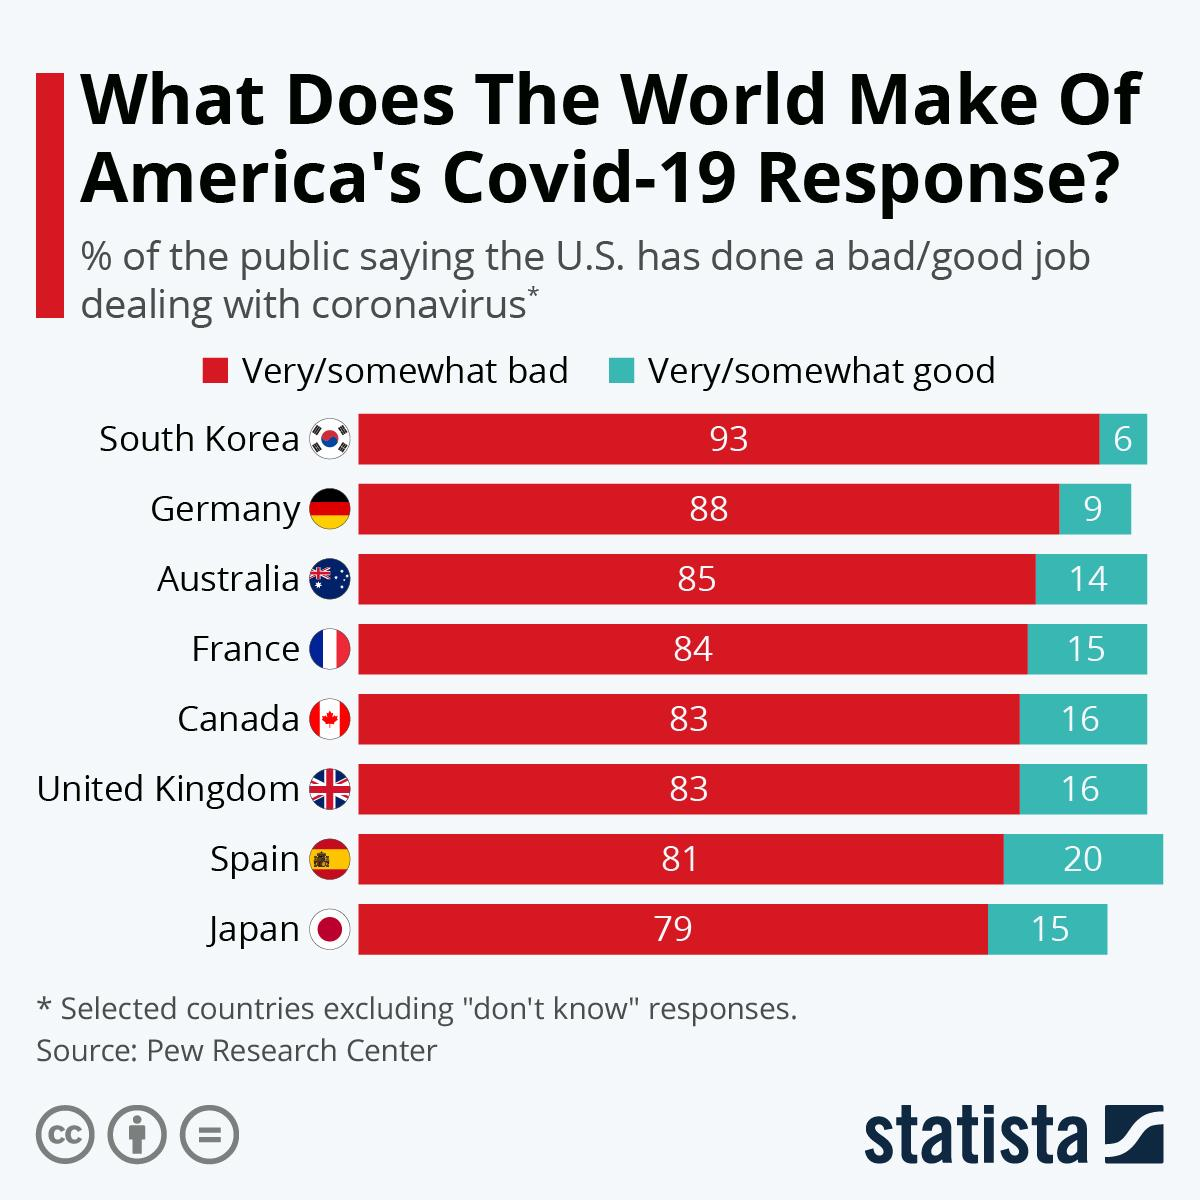Draw attention to some important aspects in this diagram. According to a recent survey, a majority of the public believe that the United States has done a good job in dealing with the COVID-19 pandemic in Canada. Specifically, 16% of the respondents stated that the U.S. has done an excellent job, while another 48% believed that the U.S. has done a good job. According to a recent survey, a significant percentage of the public believe that the United States has handled the coronavirus outbreak in Australia effectively. According to recent public opinion in France, 84% of the population believe that the United States has performed poorly in addressing the COVID-19 pandemic. A large majority of the public believe that the United States has performed poorly in dealing with the COVID-19 pandemic in Japan, with 79% of the public expressing this sentiment. According to recent polls, a significant portion of the public in Spain believe that the United States has done an excellent job in handling the coronavirus outbreak. Specifically, 20% of those surveyed gave the U.S. high marks for its efforts. 